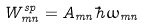Convert formula to latex. <formula><loc_0><loc_0><loc_500><loc_500>W _ { m n } ^ { s p } = A _ { m n } \hbar { \omega } _ { m n }</formula> 